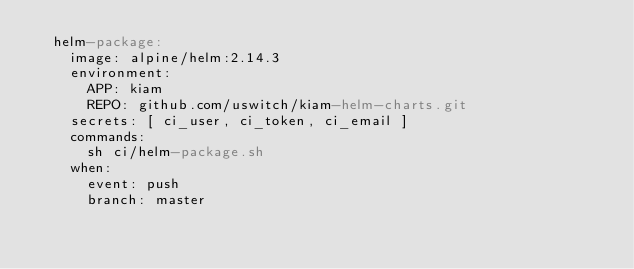Convert code to text. <code><loc_0><loc_0><loc_500><loc_500><_YAML_>  helm-package:
    image: alpine/helm:2.14.3
    environment:
      APP: kiam
      REPO: github.com/uswitch/kiam-helm-charts.git
    secrets: [ ci_user, ci_token, ci_email ]
    commands:
      sh ci/helm-package.sh
    when:
      event: push
      branch: master
</code> 